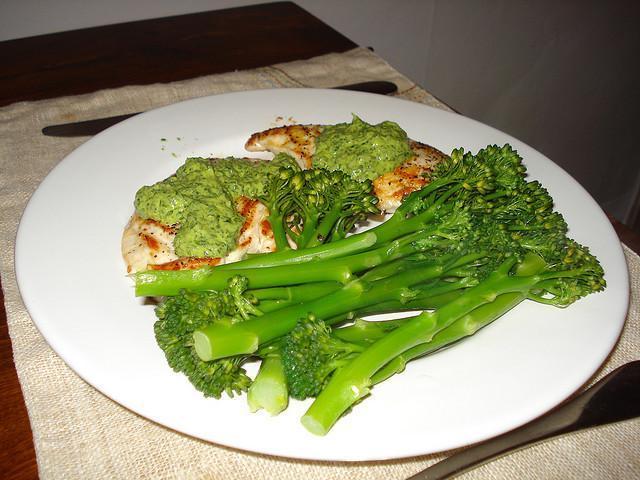How many broccolis are there?
Give a very brief answer. 2. How many people can this bike hold?
Give a very brief answer. 0. 